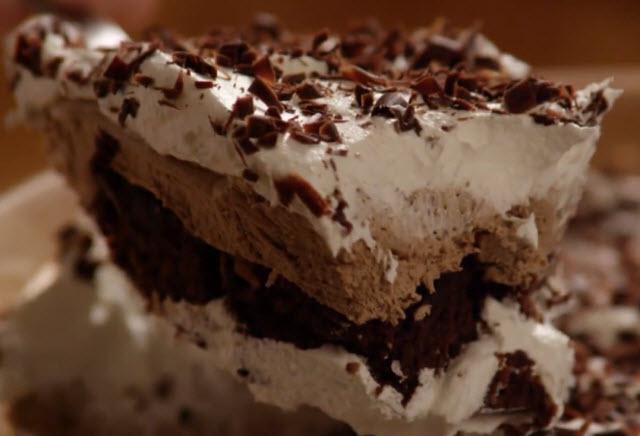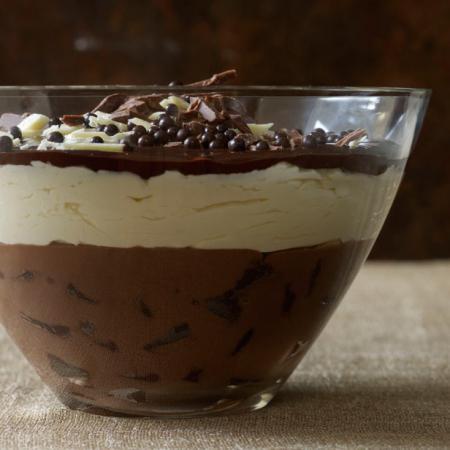The first image is the image on the left, the second image is the image on the right. For the images shown, is this caption "Left image shows a dessert served in a footed glass with crumble-type garnish nearly covering the top." true? Answer yes or no. No. 